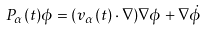<formula> <loc_0><loc_0><loc_500><loc_500>P _ { \alpha } ( t ) \phi = ( v _ { \alpha } ( t ) \cdot \nabla ) \nabla \phi + \nabla \dot { \phi }</formula> 